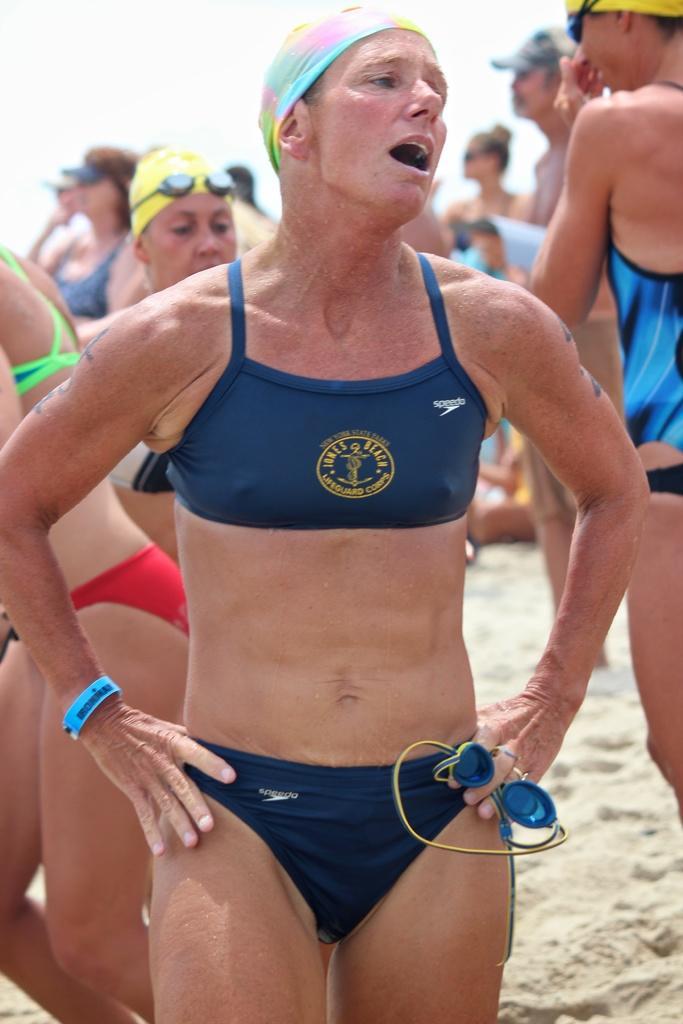Can you describe this image briefly? In the picture we can see some women are standing with a swim suits on the sand. 